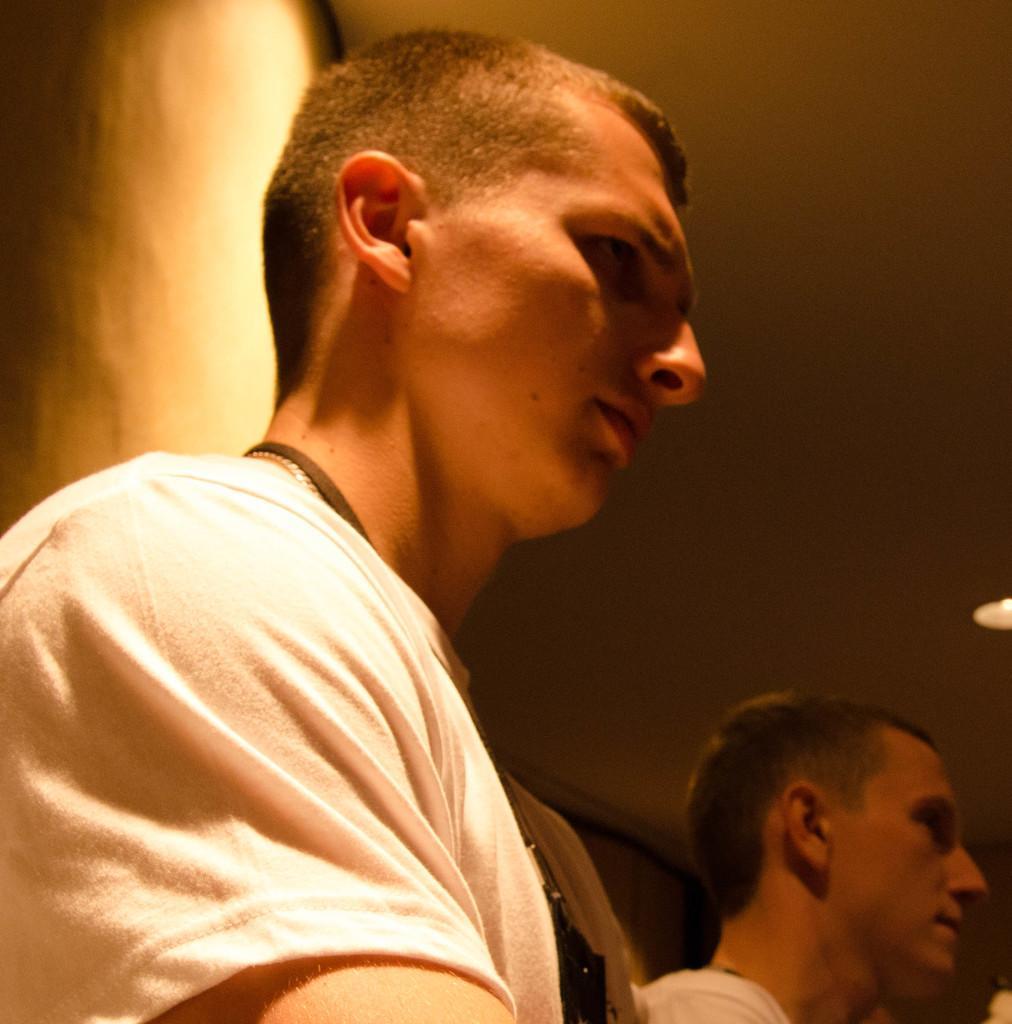In one or two sentences, can you explain what this image depicts? In this picture we can see two men were a man wore a chain, id tag and in the background we can see the wall, light. 